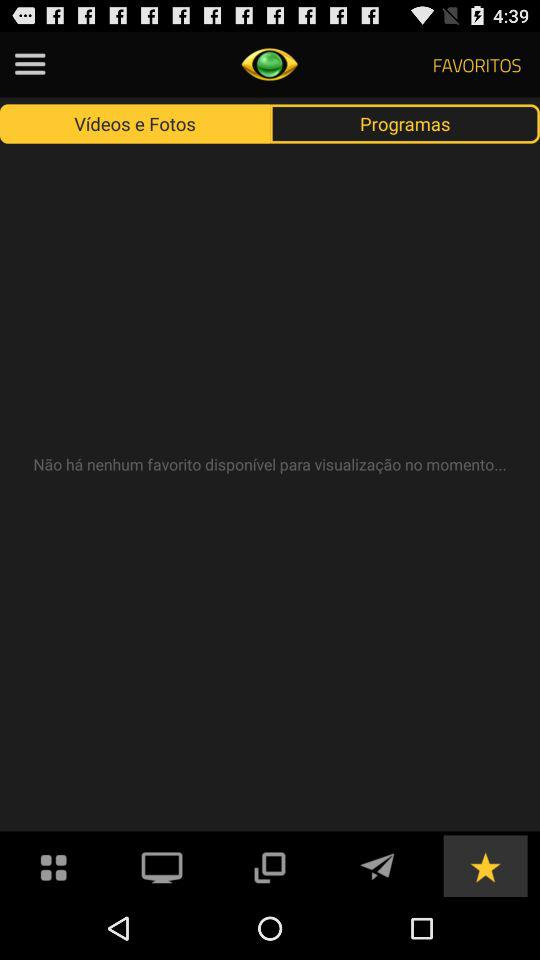Which tab has been selected? The tab that has been selected is "Vídeos e Fotos". 